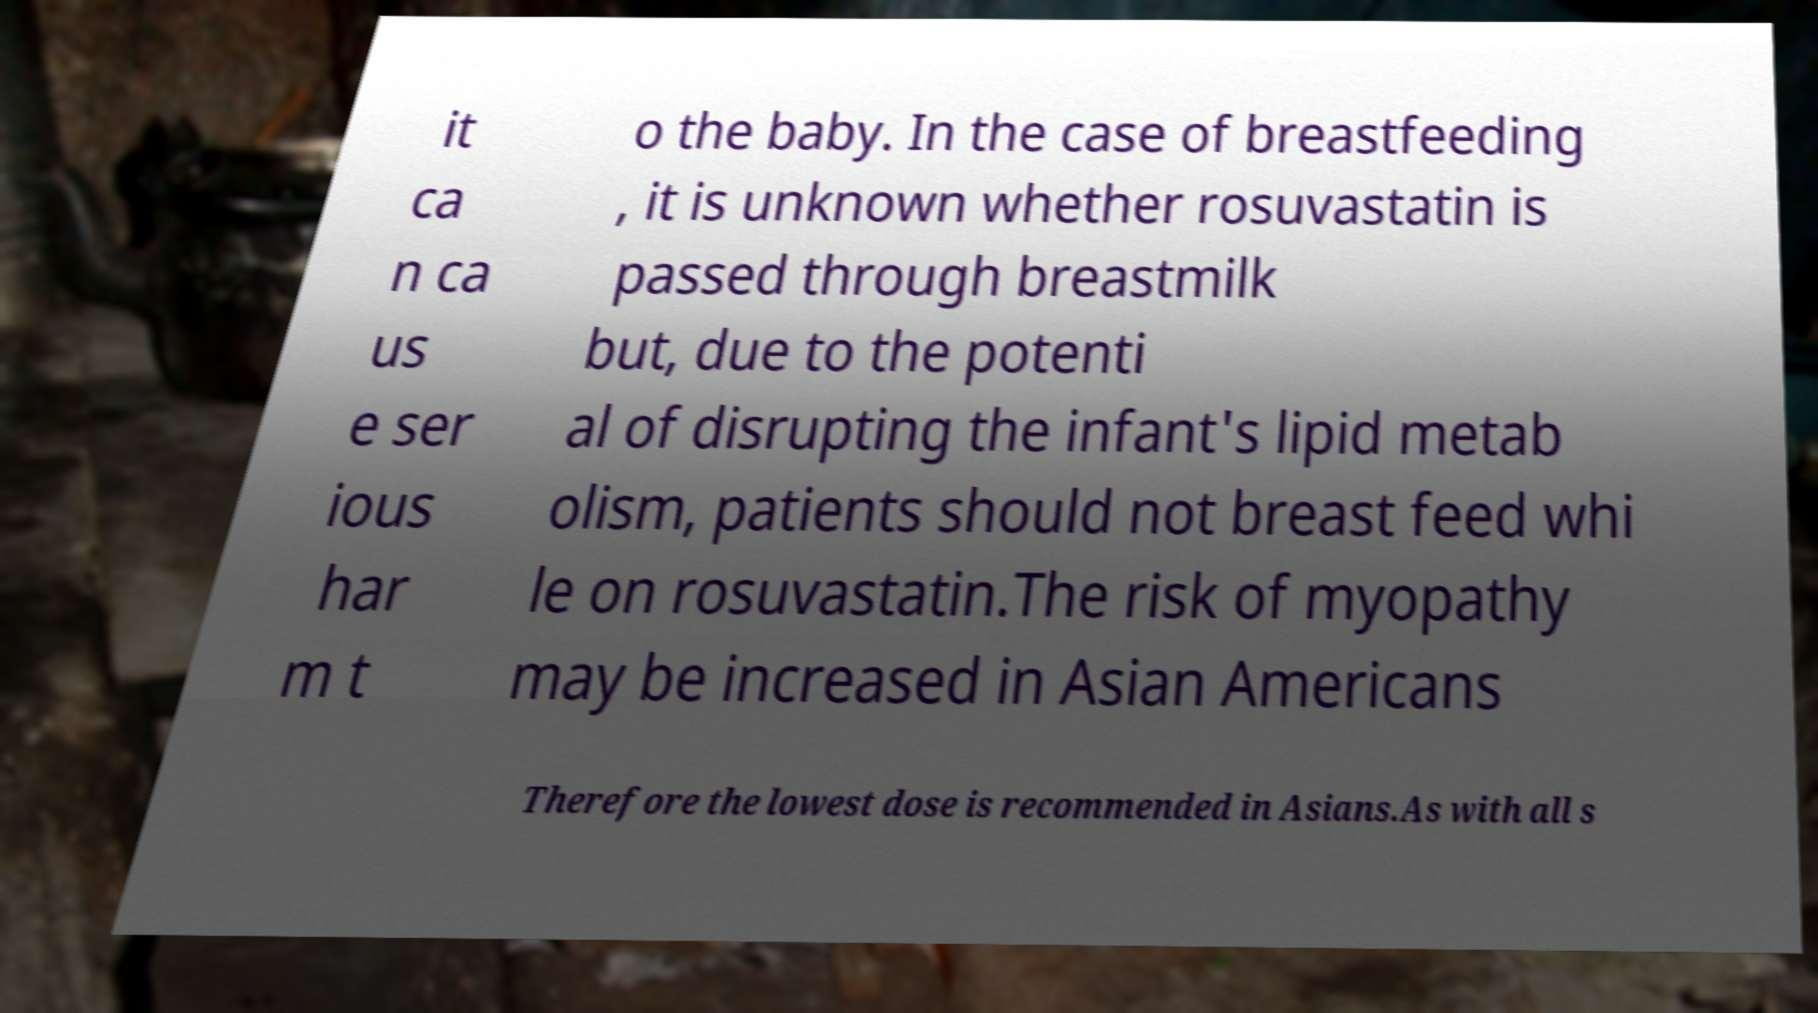Could you assist in decoding the text presented in this image and type it out clearly? it ca n ca us e ser ious har m t o the baby. In the case of breastfeeding , it is unknown whether rosuvastatin is passed through breastmilk but, due to the potenti al of disrupting the infant's lipid metab olism, patients should not breast feed whi le on rosuvastatin.The risk of myopathy may be increased in Asian Americans Therefore the lowest dose is recommended in Asians.As with all s 